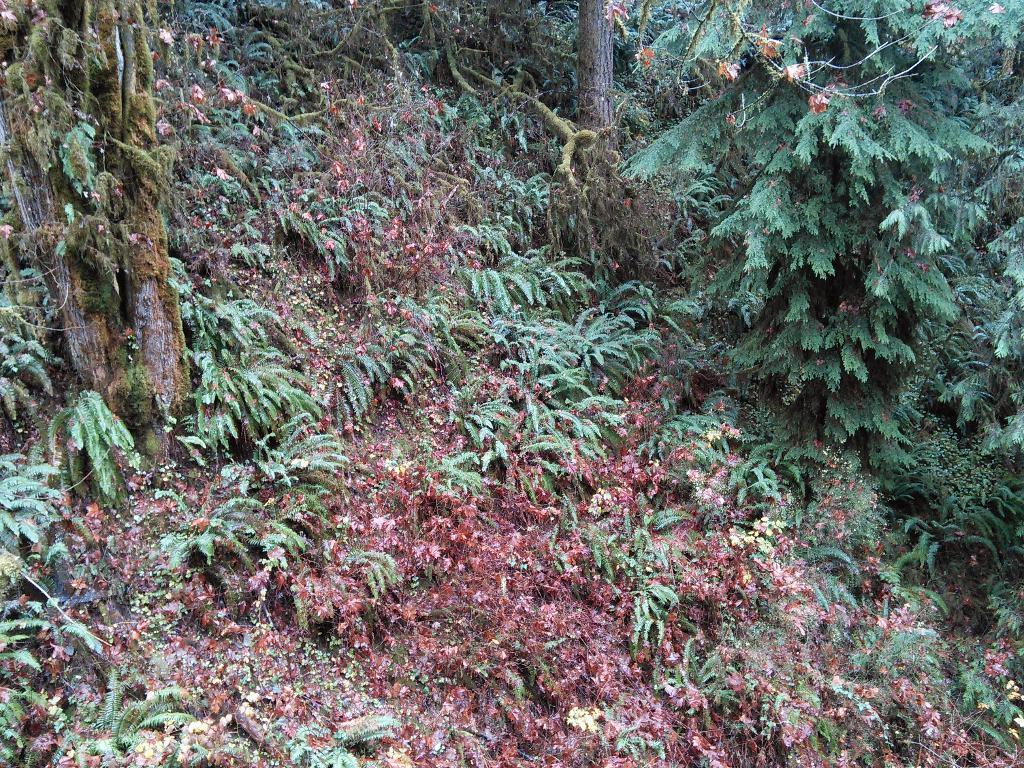How would you summarize this image in a sentence or two? This image looks like it is clicked in a forest. There are many trees and plants in this image. 